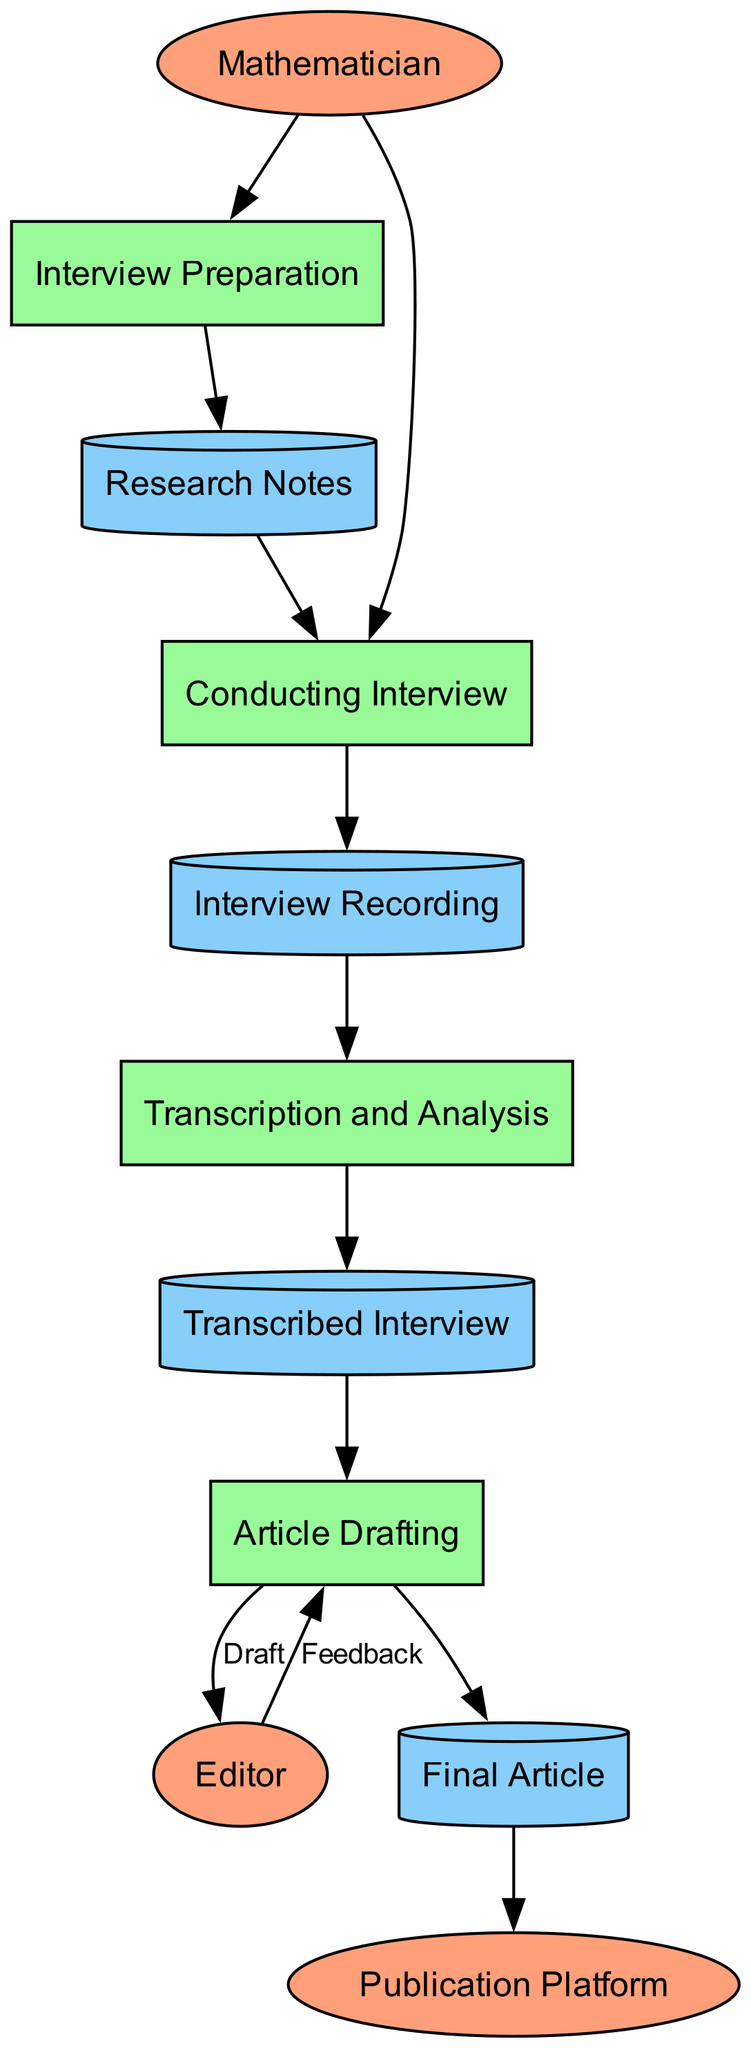What is the first process in the workflow? The first process listed in the diagram is "Interview Preparation." It is the process that follows the external entity "Mathematician."
Answer: Interview Preparation How many data stores are present in the diagram? The diagram includes three data stores: "Research Notes," "Interview Recording," and "Transcribed Interview." By counting each, we find a total of three data stores.
Answer: Three What entity provides feedback to the article drafting process? The "Editor" is the external entity that provides feedback to the article drafting process. It connects to "Article Drafting" for review and feedback.
Answer: Editor What happens after conducting the interview? After conducting the interview, the next step is "Interview Recording," where the interview is recorded in an audio or video format.
Answer: Interview Recording Which process directly follows the transcription and analysis process? The process that comes immediately after "Transcription and Analysis" is "Article Drafting." This indicates the workflow continues with drafting the article after the analysis is completed.
Answer: Article Drafting What is the final entity in the workflow? The final entity in the workflow is "Publication Platform," which indicates where the completed article is published. It comes after the output of the "Final Article."
Answer: Publication Platform What is the relationship between the "Interview Recording" and "Transcription and Analysis"? The relationship is that "Interview Recording" provides the input to "Transcription and Analysis." This implies a direct flow of information from the recording to the transcription process.
Answer: Input Which process integrates the insights from the mathematician into the article? The process that integrates the insights and creates the article is "Article Drafting." This is where the writer composes the article using the information gathered from previous steps.
Answer: Article Drafting What are the two main outputs of the "Transcription and Analysis" process? The two main outputs are "Transcribed Interview," which is the document containing the verbatim transcript, and the insights gleaned from that transcript information.
Answer: Transcribed Interview, insights 